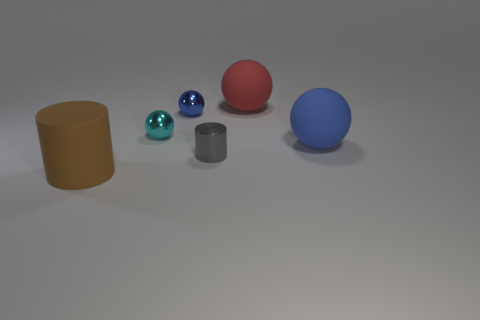Is the material of the cylinder that is behind the brown object the same as the large thing on the left side of the small blue sphere?
Ensure brevity in your answer.  No. The large rubber thing that is in front of the gray shiny object has what shape?
Make the answer very short. Cylinder. Is the number of tiny brown metallic objects less than the number of cyan metallic balls?
Make the answer very short. Yes. Are there any large objects on the right side of the cylinder that is behind the large matte thing on the left side of the metal cylinder?
Your answer should be very brief. Yes. What number of shiny things are either red balls or small cyan objects?
Provide a short and direct response. 1. What number of spheres are behind the red rubber object?
Your response must be concise. 0. How many big things are behind the metallic cylinder and in front of the red rubber thing?
Offer a very short reply. 1. What is the shape of the blue object that is made of the same material as the red sphere?
Provide a succinct answer. Sphere. There is a blue ball right of the gray cylinder; is its size the same as the blue thing on the left side of the blue rubber thing?
Ensure brevity in your answer.  No. What color is the rubber sphere that is in front of the large red rubber object?
Make the answer very short. Blue. 